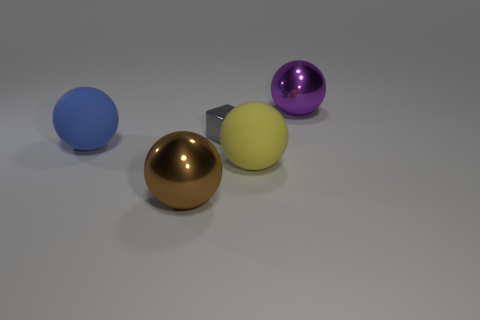Can you describe the colors and materials of the objects in the image? Certainly! There are four objects prominently displayed in the image. Starting from the left, there's a matte blue sphere, a reflective gold sphere, a smaller matte yellow cube, and to the far right, a shiny purple sphere. The materials appear to be different as well; the blue and yellow objects have a matte finish, while the gold and purple objects are glossy, indicative of metallic or reflective qualities. 